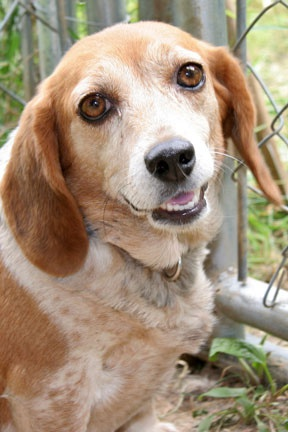Describe the objects in this image and their specific colors. I can see a dog in olive, darkgray, gray, tan, and white tones in this image. 